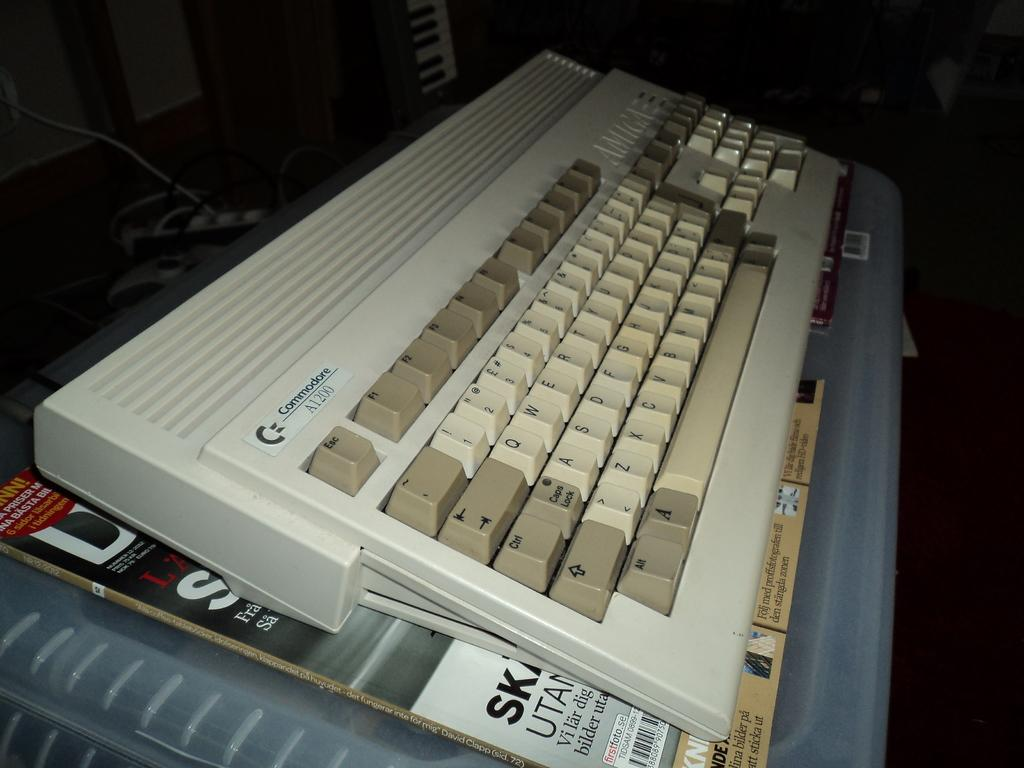What is the main object in the image? There is a keyboard in the image. What else can be seen below the keyboard? There are books with text below the keyboard. What is the third object in the image? There is a box in the image. How would you describe the background of the image? The background of the image is blurry. What type of cabbage is being used as a neck support for the keyboard in the image? There is no cabbage or neck support present in the image; it features a keyboard, books with text, and a box. 